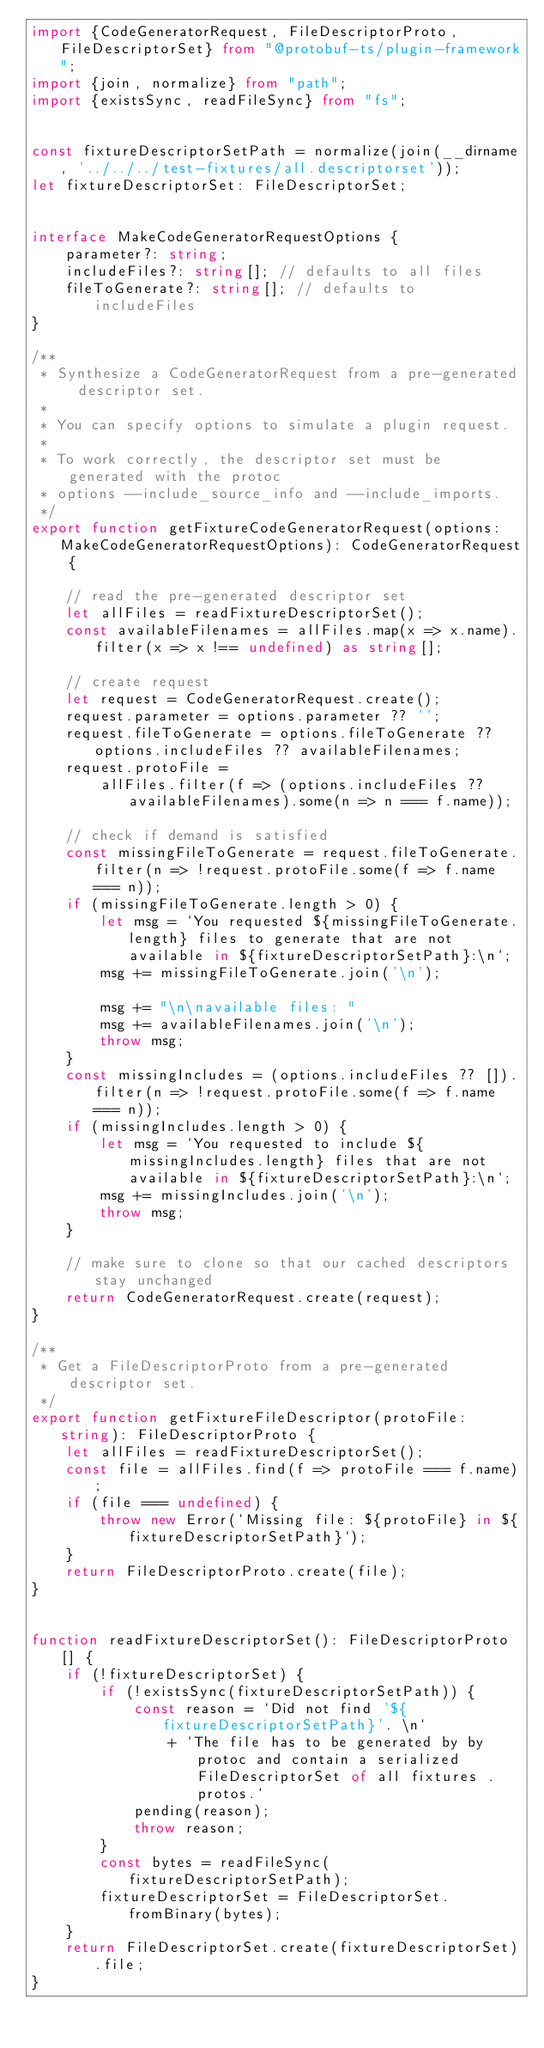Convert code to text. <code><loc_0><loc_0><loc_500><loc_500><_TypeScript_>import {CodeGeneratorRequest, FileDescriptorProto, FileDescriptorSet} from "@protobuf-ts/plugin-framework";
import {join, normalize} from "path";
import {existsSync, readFileSync} from "fs";


const fixtureDescriptorSetPath = normalize(join(__dirname, '../../../test-fixtures/all.descriptorset'));
let fixtureDescriptorSet: FileDescriptorSet;


interface MakeCodeGeneratorRequestOptions {
    parameter?: string;
    includeFiles?: string[]; // defaults to all files
    fileToGenerate?: string[]; // defaults to includeFiles
}

/**
 * Synthesize a CodeGeneratorRequest from a pre-generated descriptor set.
 *
 * You can specify options to simulate a plugin request.
 *
 * To work correctly, the descriptor set must be generated with the protoc
 * options --include_source_info and --include_imports.
 */
export function getFixtureCodeGeneratorRequest(options: MakeCodeGeneratorRequestOptions): CodeGeneratorRequest {

    // read the pre-generated descriptor set
    let allFiles = readFixtureDescriptorSet();
    const availableFilenames = allFiles.map(x => x.name).filter(x => x !== undefined) as string[];

    // create request
    let request = CodeGeneratorRequest.create();
    request.parameter = options.parameter ?? '';
    request.fileToGenerate = options.fileToGenerate ?? options.includeFiles ?? availableFilenames;
    request.protoFile =
        allFiles.filter(f => (options.includeFiles ?? availableFilenames).some(n => n === f.name));

    // check if demand is satisfied
    const missingFileToGenerate = request.fileToGenerate.filter(n => !request.protoFile.some(f => f.name === n));
    if (missingFileToGenerate.length > 0) {
        let msg = `You requested ${missingFileToGenerate.length} files to generate that are not available in ${fixtureDescriptorSetPath}:\n`;
        msg += missingFileToGenerate.join('\n');

        msg += "\n\navailable files: "
        msg += availableFilenames.join('\n');
        throw msg;
    }
    const missingIncludes = (options.includeFiles ?? []).filter(n => !request.protoFile.some(f => f.name === n));
    if (missingIncludes.length > 0) {
        let msg = `You requested to include ${missingIncludes.length} files that are not available in ${fixtureDescriptorSetPath}:\n`;
        msg += missingIncludes.join('\n');
        throw msg;
    }

    // make sure to clone so that our cached descriptors stay unchanged
    return CodeGeneratorRequest.create(request);
}

/**
 * Get a FileDescriptorProto from a pre-generated descriptor set.
 */
export function getFixtureFileDescriptor(protoFile: string): FileDescriptorProto {
    let allFiles = readFixtureDescriptorSet();
    const file = allFiles.find(f => protoFile === f.name);
    if (file === undefined) {
        throw new Error(`Missing file: ${protoFile} in ${fixtureDescriptorSetPath}`);
    }
    return FileDescriptorProto.create(file);
}


function readFixtureDescriptorSet(): FileDescriptorProto[] {
    if (!fixtureDescriptorSet) {
        if (!existsSync(fixtureDescriptorSetPath)) {
            const reason = `Did not find '${fixtureDescriptorSetPath}'. \n`
                + `The file has to be generated by by protoc and contain a serialized FileDescriptorSet of all fixtures .protos.`
            pending(reason);
            throw reason;
        }
        const bytes = readFileSync(fixtureDescriptorSetPath);
        fixtureDescriptorSet = FileDescriptorSet.fromBinary(bytes);
    }
    return FileDescriptorSet.create(fixtureDescriptorSet).file;
}
</code> 